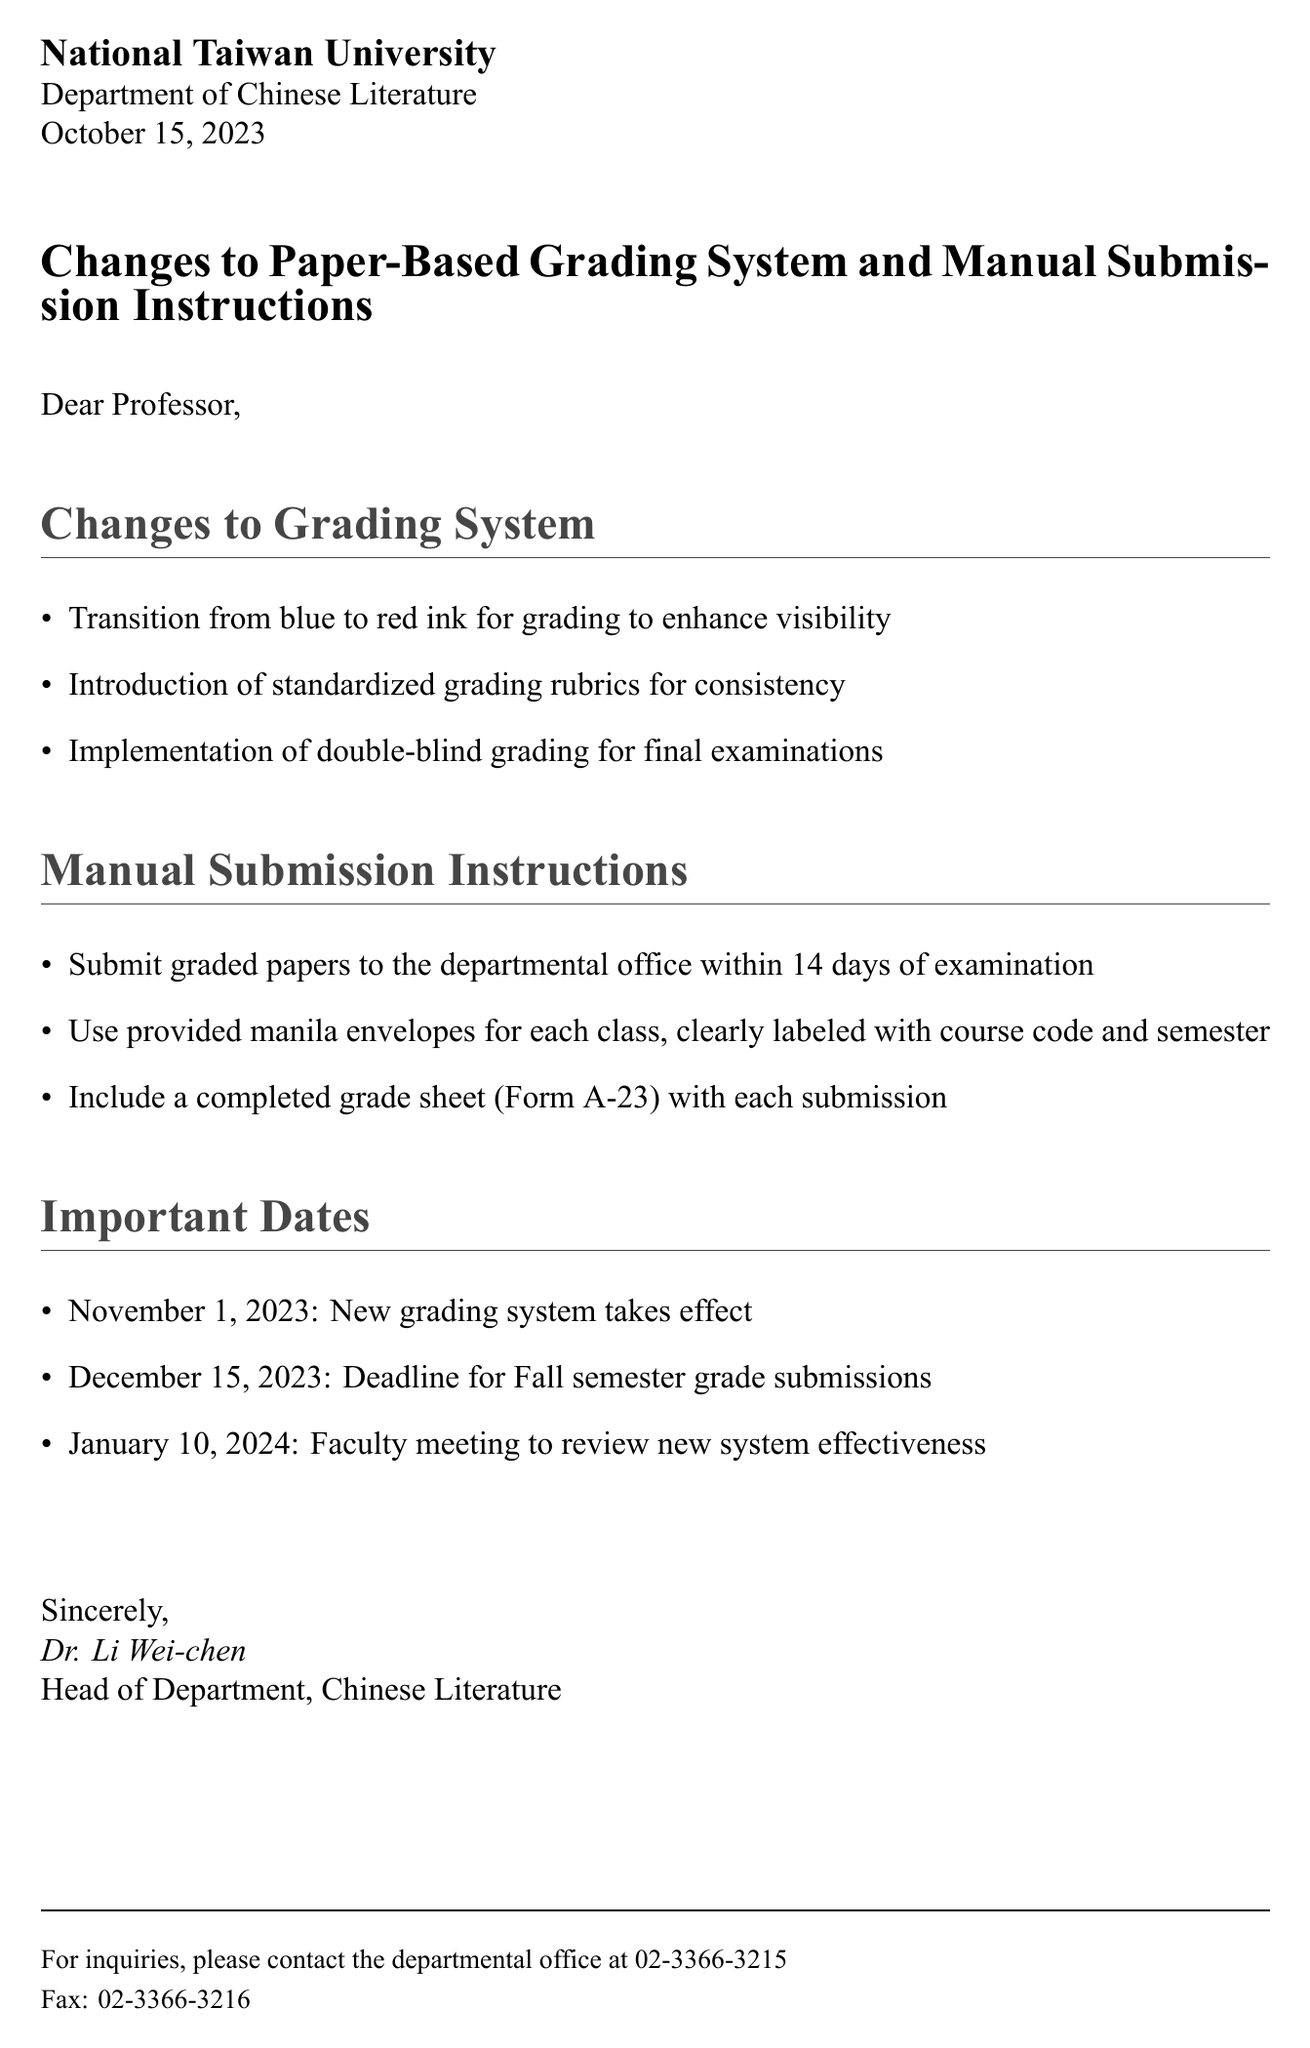What is the date of the document? The date of the document is stated at the beginning, which is October 15, 2023.
Answer: October 15, 2023 What change has been made to the grading ink? The document lists the change in grading ink, which is from blue to red ink for better visibility.
Answer: Red ink What form must be included with submissions? The document specifies that a completed grade sheet (Form A-23) must accompany submissions.
Answer: Form A-23 How many days do faculty have to submit graded papers? The instructions indicate that graded papers must be submitted within 14 days of the examination.
Answer: 14 days When does the new grading system take effect? The important dates section reveals that the new grading system starts on November 1, 2023.
Answer: November 1, 2023 What is the deadline for Fall semester grade submissions? The document states that the deadline for Fall semester grade submissions is December 15, 2023.
Answer: December 15, 2023 Who is the head of the Department of Chinese Literature? The signature at the end of the document identifies the head of the department as Dr. Li Wei-chen.
Answer: Dr. Li Wei-chen What method is being implemented for final examinations? The document highlights that double-blind grading is being implemented for final examinations for fairness and consistency.
Answer: Double-blind grading What should each manila envelope be labeled with? The manual submission instructions specify that each manila envelope must be clearly labeled with the course code and semester.
Answer: Course code and semester 